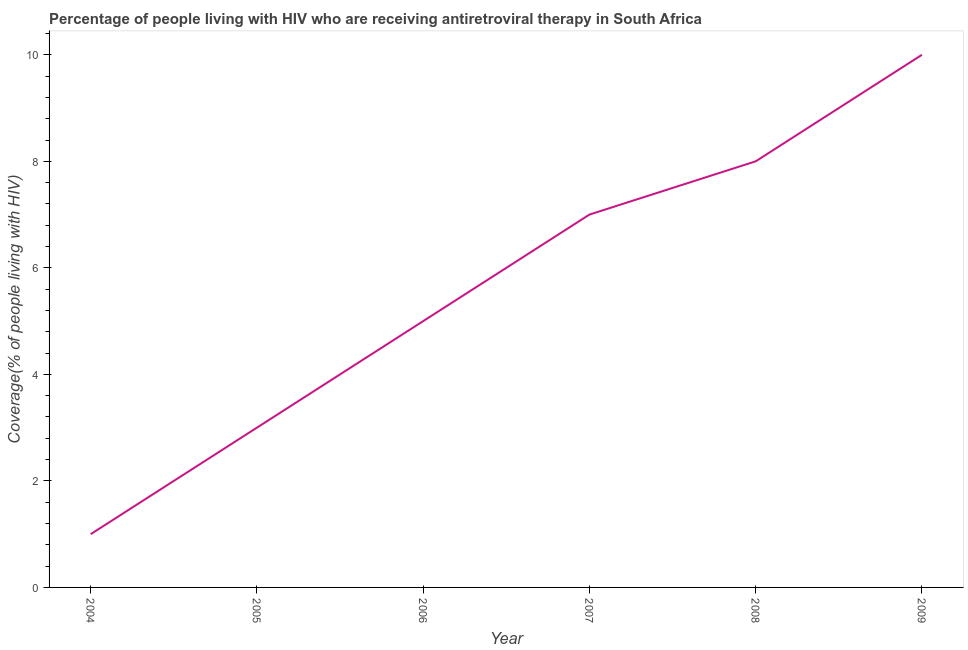What is the antiretroviral therapy coverage in 2006?
Keep it short and to the point. 5. Across all years, what is the maximum antiretroviral therapy coverage?
Offer a very short reply. 10. Across all years, what is the minimum antiretroviral therapy coverage?
Provide a short and direct response. 1. In which year was the antiretroviral therapy coverage maximum?
Offer a terse response. 2009. In which year was the antiretroviral therapy coverage minimum?
Provide a succinct answer. 2004. What is the sum of the antiretroviral therapy coverage?
Your response must be concise. 34. What is the difference between the antiretroviral therapy coverage in 2005 and 2009?
Offer a terse response. -7. What is the average antiretroviral therapy coverage per year?
Provide a short and direct response. 5.67. What is the median antiretroviral therapy coverage?
Your answer should be compact. 6. In how many years, is the antiretroviral therapy coverage greater than 7.6 %?
Your response must be concise. 2. What is the ratio of the antiretroviral therapy coverage in 2005 to that in 2006?
Your answer should be compact. 0.6. Is the antiretroviral therapy coverage in 2007 less than that in 2009?
Your answer should be very brief. Yes. What is the difference between the highest and the second highest antiretroviral therapy coverage?
Make the answer very short. 2. Is the sum of the antiretroviral therapy coverage in 2005 and 2007 greater than the maximum antiretroviral therapy coverage across all years?
Provide a succinct answer. No. What is the difference between the highest and the lowest antiretroviral therapy coverage?
Your answer should be compact. 9. In how many years, is the antiretroviral therapy coverage greater than the average antiretroviral therapy coverage taken over all years?
Your answer should be very brief. 3. How many years are there in the graph?
Ensure brevity in your answer.  6. What is the difference between two consecutive major ticks on the Y-axis?
Make the answer very short. 2. Does the graph contain any zero values?
Keep it short and to the point. No. Does the graph contain grids?
Offer a very short reply. No. What is the title of the graph?
Your answer should be compact. Percentage of people living with HIV who are receiving antiretroviral therapy in South Africa. What is the label or title of the X-axis?
Make the answer very short. Year. What is the label or title of the Y-axis?
Make the answer very short. Coverage(% of people living with HIV). What is the Coverage(% of people living with HIV) of 2006?
Offer a very short reply. 5. What is the Coverage(% of people living with HIV) of 2008?
Your answer should be very brief. 8. What is the difference between the Coverage(% of people living with HIV) in 2004 and 2007?
Your answer should be very brief. -6. What is the difference between the Coverage(% of people living with HIV) in 2004 and 2008?
Provide a short and direct response. -7. What is the difference between the Coverage(% of people living with HIV) in 2005 and 2006?
Offer a very short reply. -2. What is the difference between the Coverage(% of people living with HIV) in 2005 and 2008?
Your answer should be very brief. -5. What is the difference between the Coverage(% of people living with HIV) in 2005 and 2009?
Make the answer very short. -7. What is the difference between the Coverage(% of people living with HIV) in 2006 and 2009?
Provide a succinct answer. -5. What is the ratio of the Coverage(% of people living with HIV) in 2004 to that in 2005?
Offer a very short reply. 0.33. What is the ratio of the Coverage(% of people living with HIV) in 2004 to that in 2007?
Provide a succinct answer. 0.14. What is the ratio of the Coverage(% of people living with HIV) in 2004 to that in 2009?
Make the answer very short. 0.1. What is the ratio of the Coverage(% of people living with HIV) in 2005 to that in 2006?
Give a very brief answer. 0.6. What is the ratio of the Coverage(% of people living with HIV) in 2005 to that in 2007?
Offer a very short reply. 0.43. What is the ratio of the Coverage(% of people living with HIV) in 2006 to that in 2007?
Keep it short and to the point. 0.71. What is the ratio of the Coverage(% of people living with HIV) in 2006 to that in 2008?
Offer a very short reply. 0.62. What is the ratio of the Coverage(% of people living with HIV) in 2007 to that in 2008?
Offer a very short reply. 0.88. 